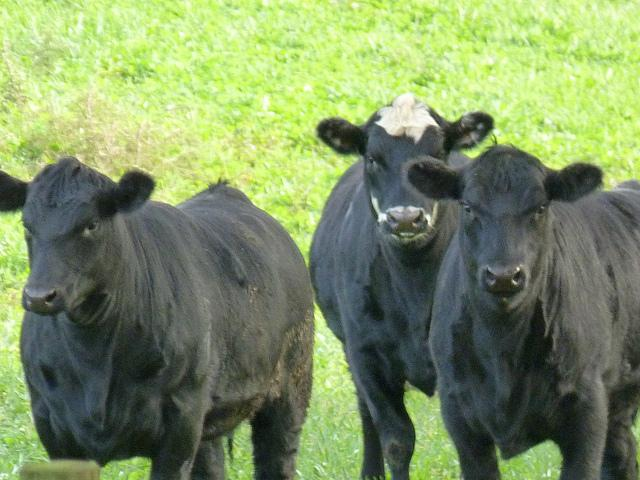What color is on the animal in the middle's head? Please explain your reasoning. white. Black and white cows are standing together in a pasture. 